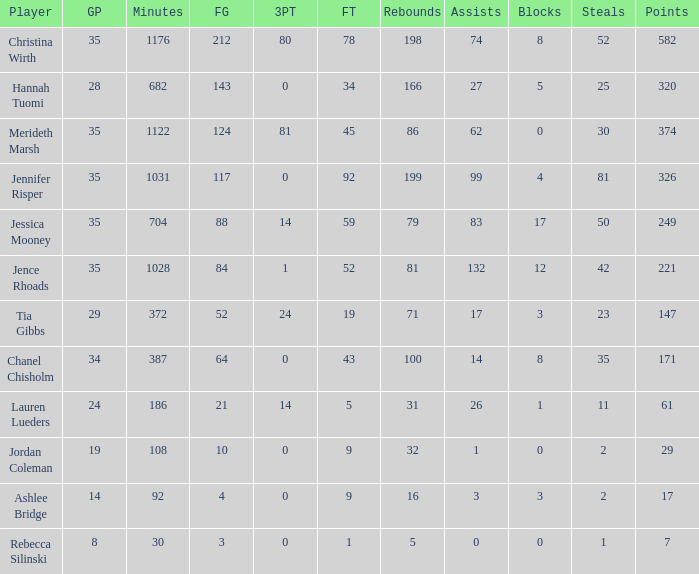For how many minutes did chanel chisholm participate in the game? 1.0. 